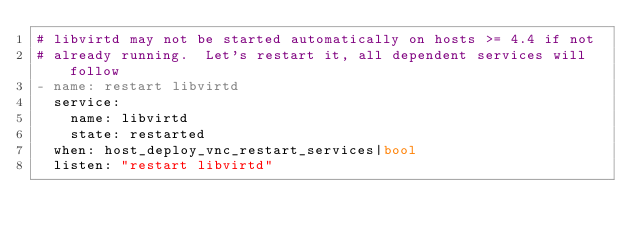<code> <loc_0><loc_0><loc_500><loc_500><_YAML_># libvirtd may not be started automatically on hosts >= 4.4 if not
# already running.  Let's restart it, all dependent services will follow
- name: restart libvirtd
  service:
    name: libvirtd
    state: restarted
  when: host_deploy_vnc_restart_services|bool
  listen: "restart libvirtd"
</code> 